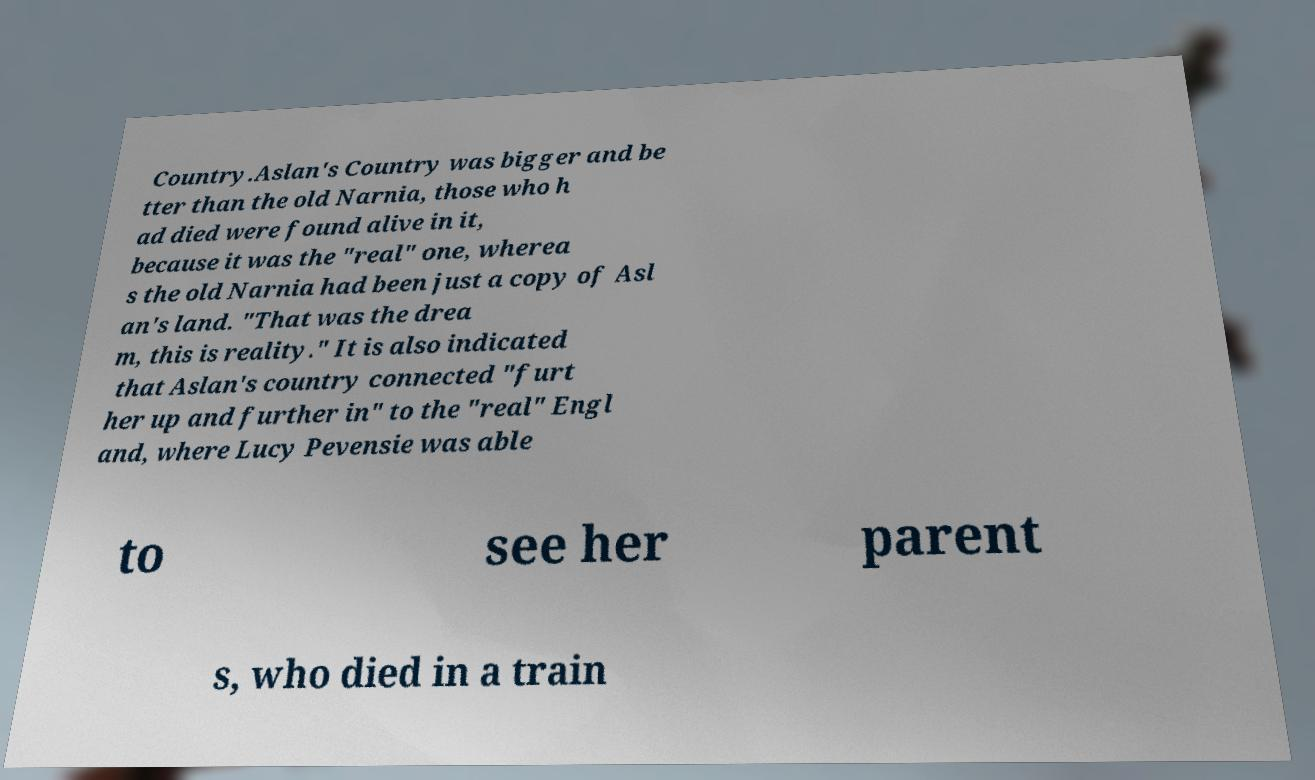Could you extract and type out the text from this image? Country.Aslan's Country was bigger and be tter than the old Narnia, those who h ad died were found alive in it, because it was the "real" one, wherea s the old Narnia had been just a copy of Asl an's land. "That was the drea m, this is reality." It is also indicated that Aslan's country connected "furt her up and further in" to the "real" Engl and, where Lucy Pevensie was able to see her parent s, who died in a train 